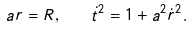<formula> <loc_0><loc_0><loc_500><loc_500>a r = R , \quad \dot { t } ^ { 2 } = 1 + a ^ { 2 } { \dot { r } } ^ { 2 } .</formula> 